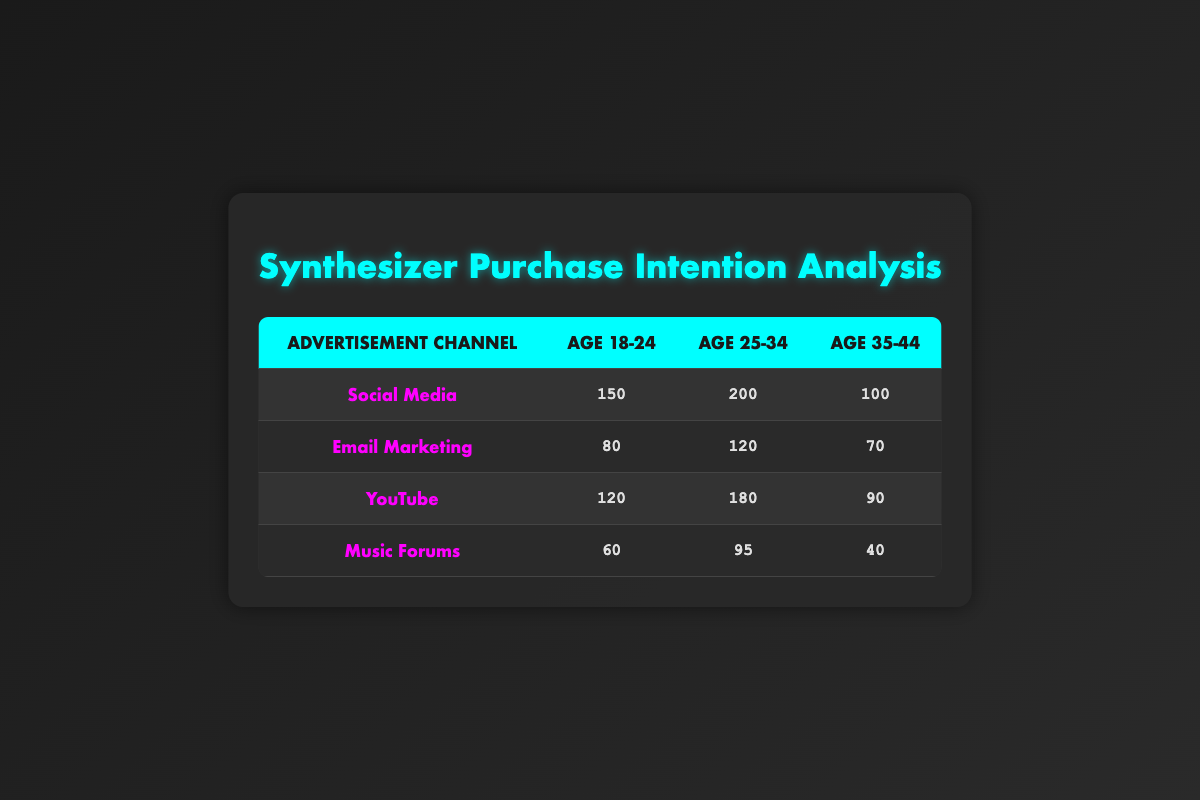What demographic shows the highest purchase intention through Social Media? In the Social Media row, the counts for different age groups are 150 for Age 18-24, 200 for Age 25-34, and 100 for Age 35-44. The highest count is for Age 25-34.
Answer: Age 25-34 Which advertisement channel has the lowest overall purchase intention? To determine the lowest overall intention, sum the counts for each channel: Social Media (150 + 200 + 100 = 450), Email Marketing (80 + 120 + 70 = 270), YouTube (120 + 180 + 90 = 390), Music Forums (60 + 95 + 40 = 195). The lowest total is for Music Forums.
Answer: Music Forums Are more people intending to purchase synthesizers via YouTube than Email Marketing for the Age 25-34 demographic? In the Age 25-34 column, YouTube has a count of 180 while Email Marketing has a count of 120. Since 180 is greater than 120, the answer is yes.
Answer: Yes What is the total purchase intention count for the Age 18-24 demographic across all advertisement channels? The counts for Age 18-24 are 150 (Social Media) + 80 (Email Marketing) + 120 (YouTube) + 60 (Music Forums) = 410.
Answer: 410 Which age group shows the most consistent interest across all advertisement channels? To find the most consistent interest, we can analyze the differences in counts for each age group. For Age 18-24: 150, 80, 120, and 60 → differences are 70, 30, and 60. For Age 25-34: 200, 120, 180, and 95 → differences are 80, 100, and 85. For Age 35-44: 100, 70, 90, and 40 → differences are 30, 20, and 50. The Age 35-44 group has the smallest differences overall showing the most consistency.
Answer: Age 35-44 What is the average purchase intention count for the Age 35-44 demographic? The purchase intention counts for Age 35-44 are 100 (Social Media), 70 (Email Marketing), 90 (YouTube), and 40 (Music Forums). Summing these values gives 100 + 70 + 90 + 40 = 300. There are 4 entries, so the average is 300 / 4 = 75.
Answer: 75 